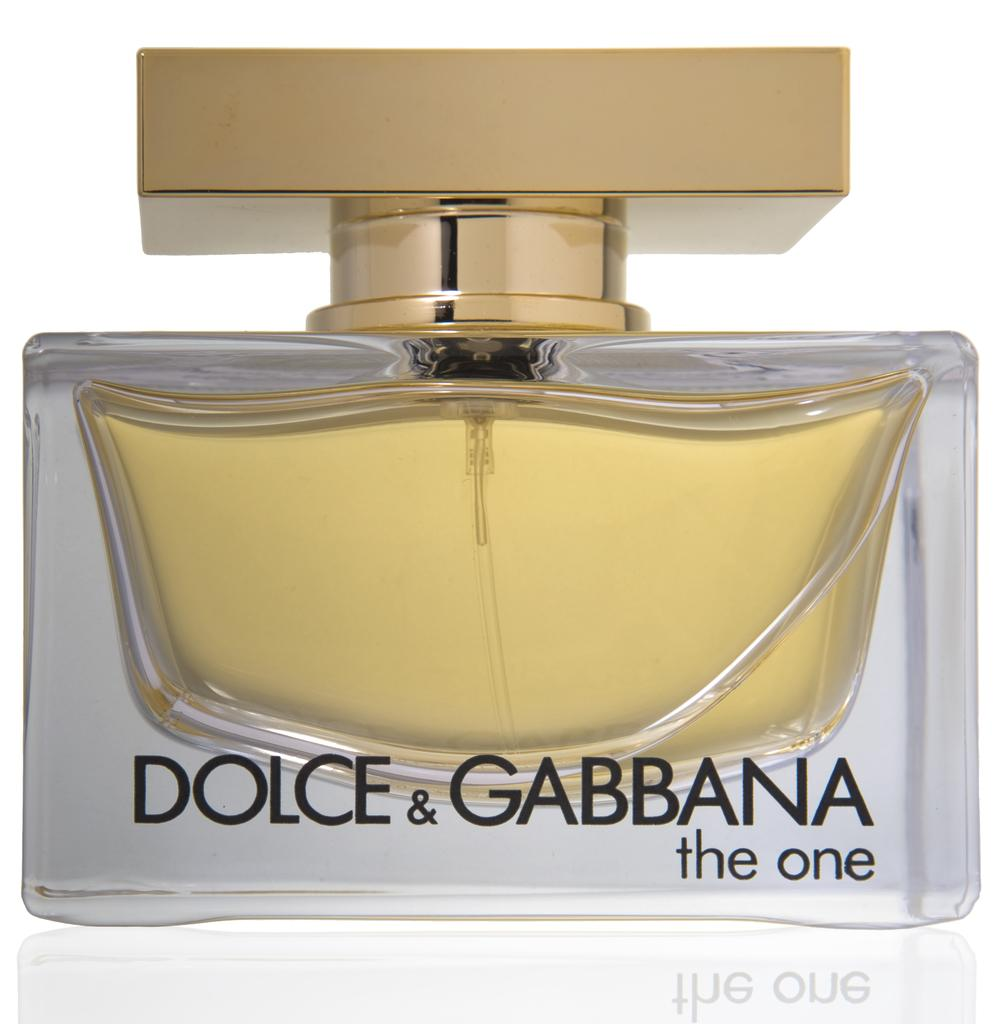<image>
Give a short and clear explanation of the subsequent image. A fancy bottle of perfume by Dolce & Gabbana labeled on the front of the bottle. 